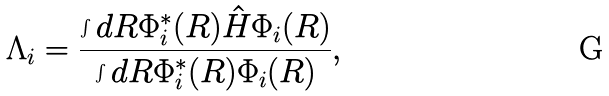<formula> <loc_0><loc_0><loc_500><loc_500>\Lambda _ { i } = \frac { \int d R \Phi _ { i } ^ { * } ( R ) \hat { H } \Phi _ { i } ( R ) } { \int d R \Phi _ { i } ^ { * } ( R ) \Phi _ { i } ( R ) } ,</formula> 